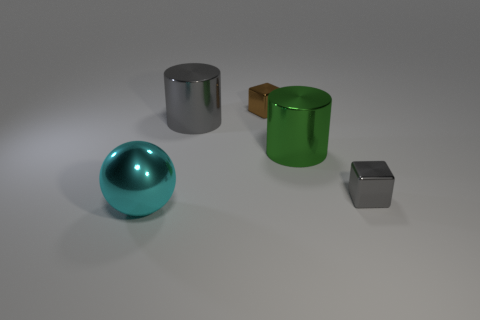What number of things are either small metal things that are behind the gray cylinder or large objects behind the small gray thing?
Ensure brevity in your answer.  3. There is a cyan shiny ball; are there any large gray metal things right of it?
Provide a short and direct response. Yes. What number of objects are either big things behind the gray metal cube or cyan things?
Give a very brief answer. 3. What number of green objects are small blocks or metal spheres?
Provide a short and direct response. 0. Are there fewer small blocks that are behind the big green object than cubes?
Keep it short and to the point. Yes. What color is the small thing that is on the left side of the tiny gray shiny object that is in front of the tiny block that is behind the tiny gray shiny cube?
Offer a very short reply. Brown. What size is the other metallic thing that is the same shape as the big green shiny object?
Your answer should be very brief. Large. Is the number of large objects in front of the ball less than the number of shiny cubes on the left side of the tiny gray shiny object?
Your response must be concise. Yes. What shape is the metallic object that is in front of the green shiny thing and right of the big cyan sphere?
Your answer should be compact. Cube. What size is the brown object that is made of the same material as the large cyan ball?
Provide a succinct answer. Small. 